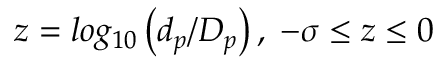<formula> <loc_0><loc_0><loc_500><loc_500>z = \log _ { 1 0 } \left ( d _ { p } / D _ { p } \right ) , \, - \sigma \leq z \leq 0</formula> 